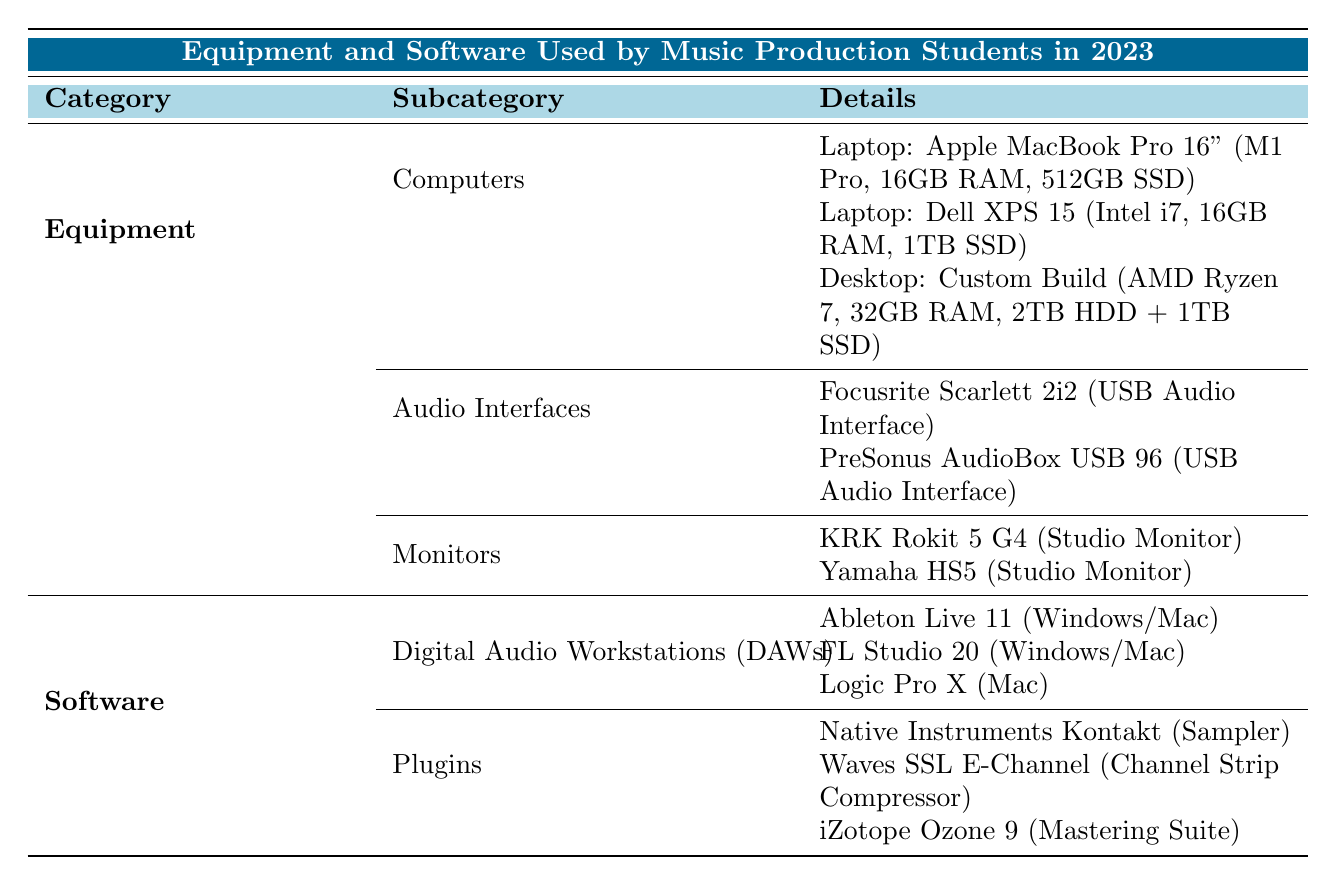What brands of laptops are listed in the table? The table lists two laptop brands: Apple and Dell. The specific models mentioned are the MacBook Pro 16" and XPS 15.
Answer: Apple, Dell What is the total RAM capacity for the custom desktop build? The custom desktop build has a RAM capacity of 32GB as specified in the details.
Answer: 32GB Is iZotope Ozone 9 a plugin used for sampling? iZotope Ozone 9 is categorized as a mastering suite in the table, not a sampler, so the answer is no.
Answer: No How many audio interfaces are mentioned in the table? Two audio interfaces are listed: Focusrite Scarlett 2i2 and PreSonus AudioBox USB 96, thus the total count is two.
Answer: 2 Which laptop has the highest storage capacity? The Dell XPS 15 has a storage capacity of 1TB SSD and the custom desktop has a total of 3TB (2TB HDD + 1TB SSD), making the custom desktop the highest.
Answer: Custom Build What is the most common platform for the listed Digital Audio Workstations? Both Ableton Live 11 and FL Studio 20 are available on Windows/Mac, which makes this the most common platform for the listed DAWs.
Answer: Windows/Mac Do all the studio monitors listed use the same type? The table lists two studio monitors: KRK Rokit 5 G4 and Yamaha HS5 which are both classified under the type studio monitor, indicating they share the same type.
Answer: Yes What is the average RAM size of the laptops listed? The RAM specifications for the laptops are both 16GB, so the average RAM size calculation is (16 + 16) / 2 = 16GB.
Answer: 16GB What type of plugin is Waves SSL E-Channel categorized as? According to the table, Waves SSL E-Channel is categorized as a channel strip compressor.
Answer: Channel Strip Compressor 